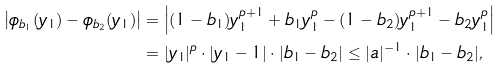Convert formula to latex. <formula><loc_0><loc_0><loc_500><loc_500>\left | \phi _ { b _ { 1 } } ( y _ { 1 } ) - \phi _ { b _ { 2 } } ( y _ { 1 } ) \right | & = \left | ( 1 - b _ { 1 } ) y _ { 1 } ^ { p + 1 } + b _ { 1 } y _ { 1 } ^ { p } - ( 1 - b _ { 2 } ) y _ { 1 } ^ { p + 1 } - b _ { 2 } y _ { 1 } ^ { p } \right | \\ & = | y _ { 1 } | ^ { p } \cdot | y _ { 1 } - 1 | \cdot | b _ { 1 } - b _ { 2 } | \leq | a | ^ { - 1 } \cdot | b _ { 1 } - b _ { 2 } | ,</formula> 